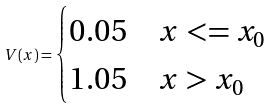Convert formula to latex. <formula><loc_0><loc_0><loc_500><loc_500>V ( x ) = \begin{cases} 0 . 0 5 & x < = x _ { 0 } \\ 1 . 0 5 & x > x _ { 0 } \\ \end{cases}</formula> 